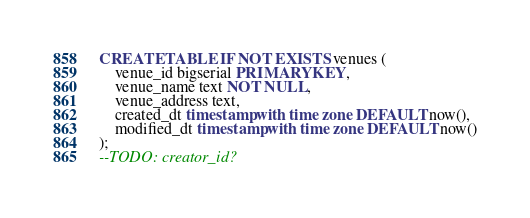<code> <loc_0><loc_0><loc_500><loc_500><_SQL_>CREATE TABLE IF NOT EXISTS venues (
    venue_id bigserial PRIMARY KEY,
    venue_name text NOT NULL,
    venue_address text,
    created_dt timestamp with time zone DEFAULT now(),
    modified_dt timestamp with time zone DEFAULT now()
);
--TODO: creator_id?
</code> 